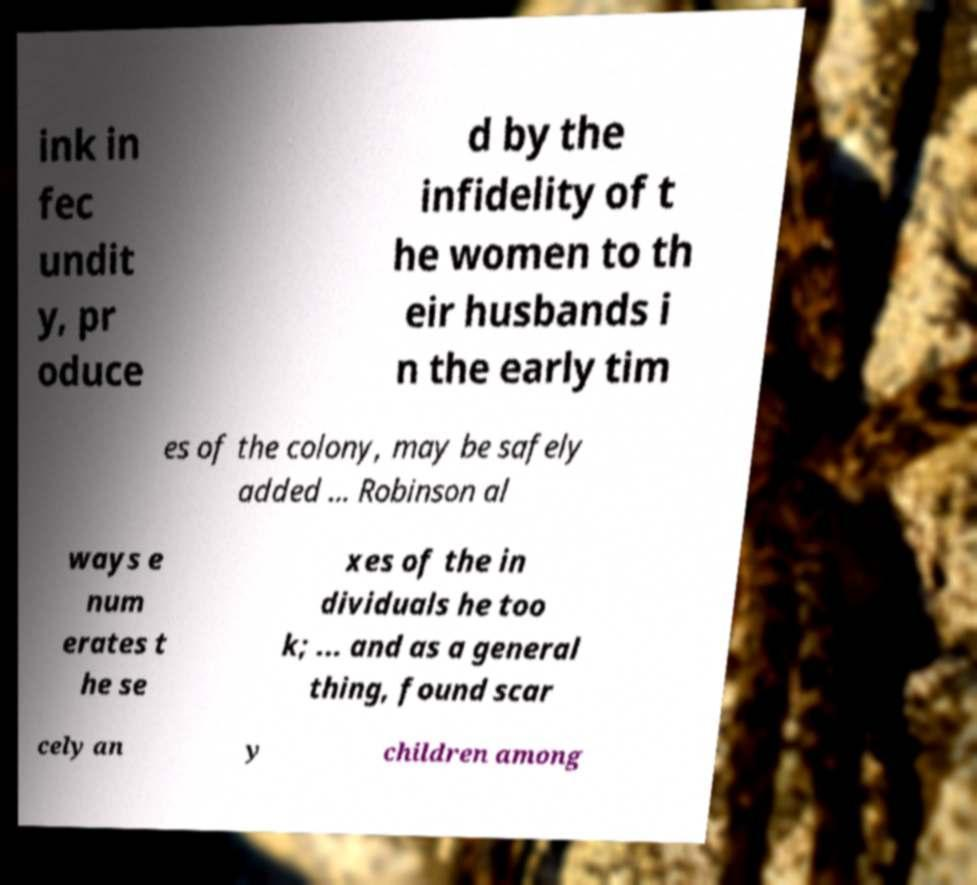What messages or text are displayed in this image? I need them in a readable, typed format. ink in fec undit y, pr oduce d by the infidelity of t he women to th eir husbands i n the early tim es of the colony, may be safely added ... Robinson al ways e num erates t he se xes of the in dividuals he too k; ... and as a general thing, found scar cely an y children among 